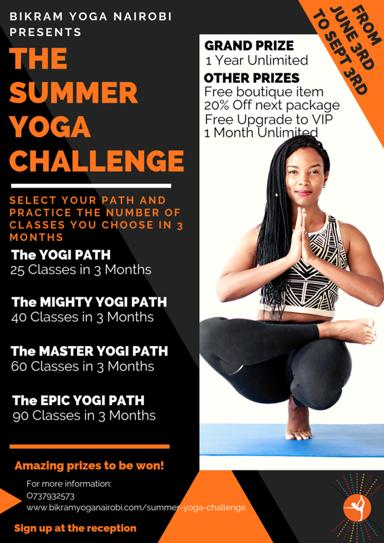What are the different paths one can choose to participate in the challenge? Participants in the Summer Yoga Challenge can select from four exciting paths, tailored to different levels of commitment and intensity: 1. The Yogi Path with 25 classes in 3 months, 2. The Mighty Yogi Path with 40 classes, 3. The Master Yogi Path pushing the boundaries with 60 classes, and 4. The Epic Yogi Path, the ultimate test with 90 classes. Each path offers a unique opportunity to deepen one's yoga practice. 